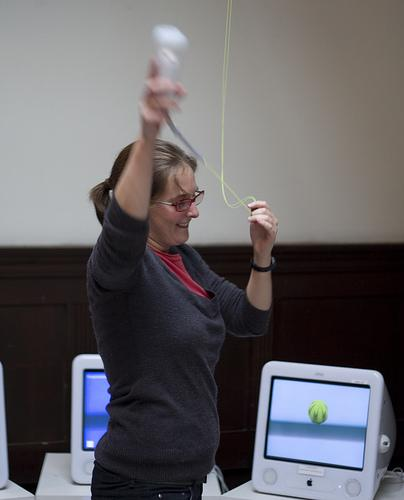Describe the emotions displayed by the woman in the image. The woman appears happy, relaxed, and engaged in playing Wii, as she is smiling with her teeth showing and holding the remote in her hand. Mention the key elements and actions in the picture. Woman holding Wii remote, wearing watch and glasses, Apple computer with logo, two computers on desks, and woman smiling with teeth showing. Explain the setting and ambiance of the image. The image portrays a casual and fun office atmosphere, with the woman wearing black shirt and glasses engaged in a Wii game. Describe the woman's attire and her activity in the image. The woman, wearing red glasses, a black shirt, jeans, and a watch on her left arm, is holding a Wii remote and playing in an office. Provide a brief overview of the scene captured in the image. A woman wearing glasses and a black shirt is playing Wii in an office with two computers on desks, one having an Apple computer and old logo. Write a short sentence describing the primary focus of the image. A cheerful woman in glasses and black shirt is playing Wii in an office setting with computers on desks. Explain the image's main subject and their appearance. The image shows a smiling, glasses-wearing woman with a low ponytail, dressed in a black shirt and jeans, playing Wii. In one sentence, summarize the most noticeable aspects of the image. A woman in glasses and black attire enjoys playing Wii in an office with an Apple computer and CRT monitor on desks. Using one sentence, detail the primary elements of the image, focusing on the woman. A smiling woman with glasses, in black shirt and jeans, is playfully holding a Wii remote in front of a table with an Apple computer and CRT monitor. Give a brief description of the technical aspects of the image focusing on the electronics. The image features an Apple computer with old logo, two computer monitors turned on, a Wii TV screen on a table, and a woman playing Wii. 